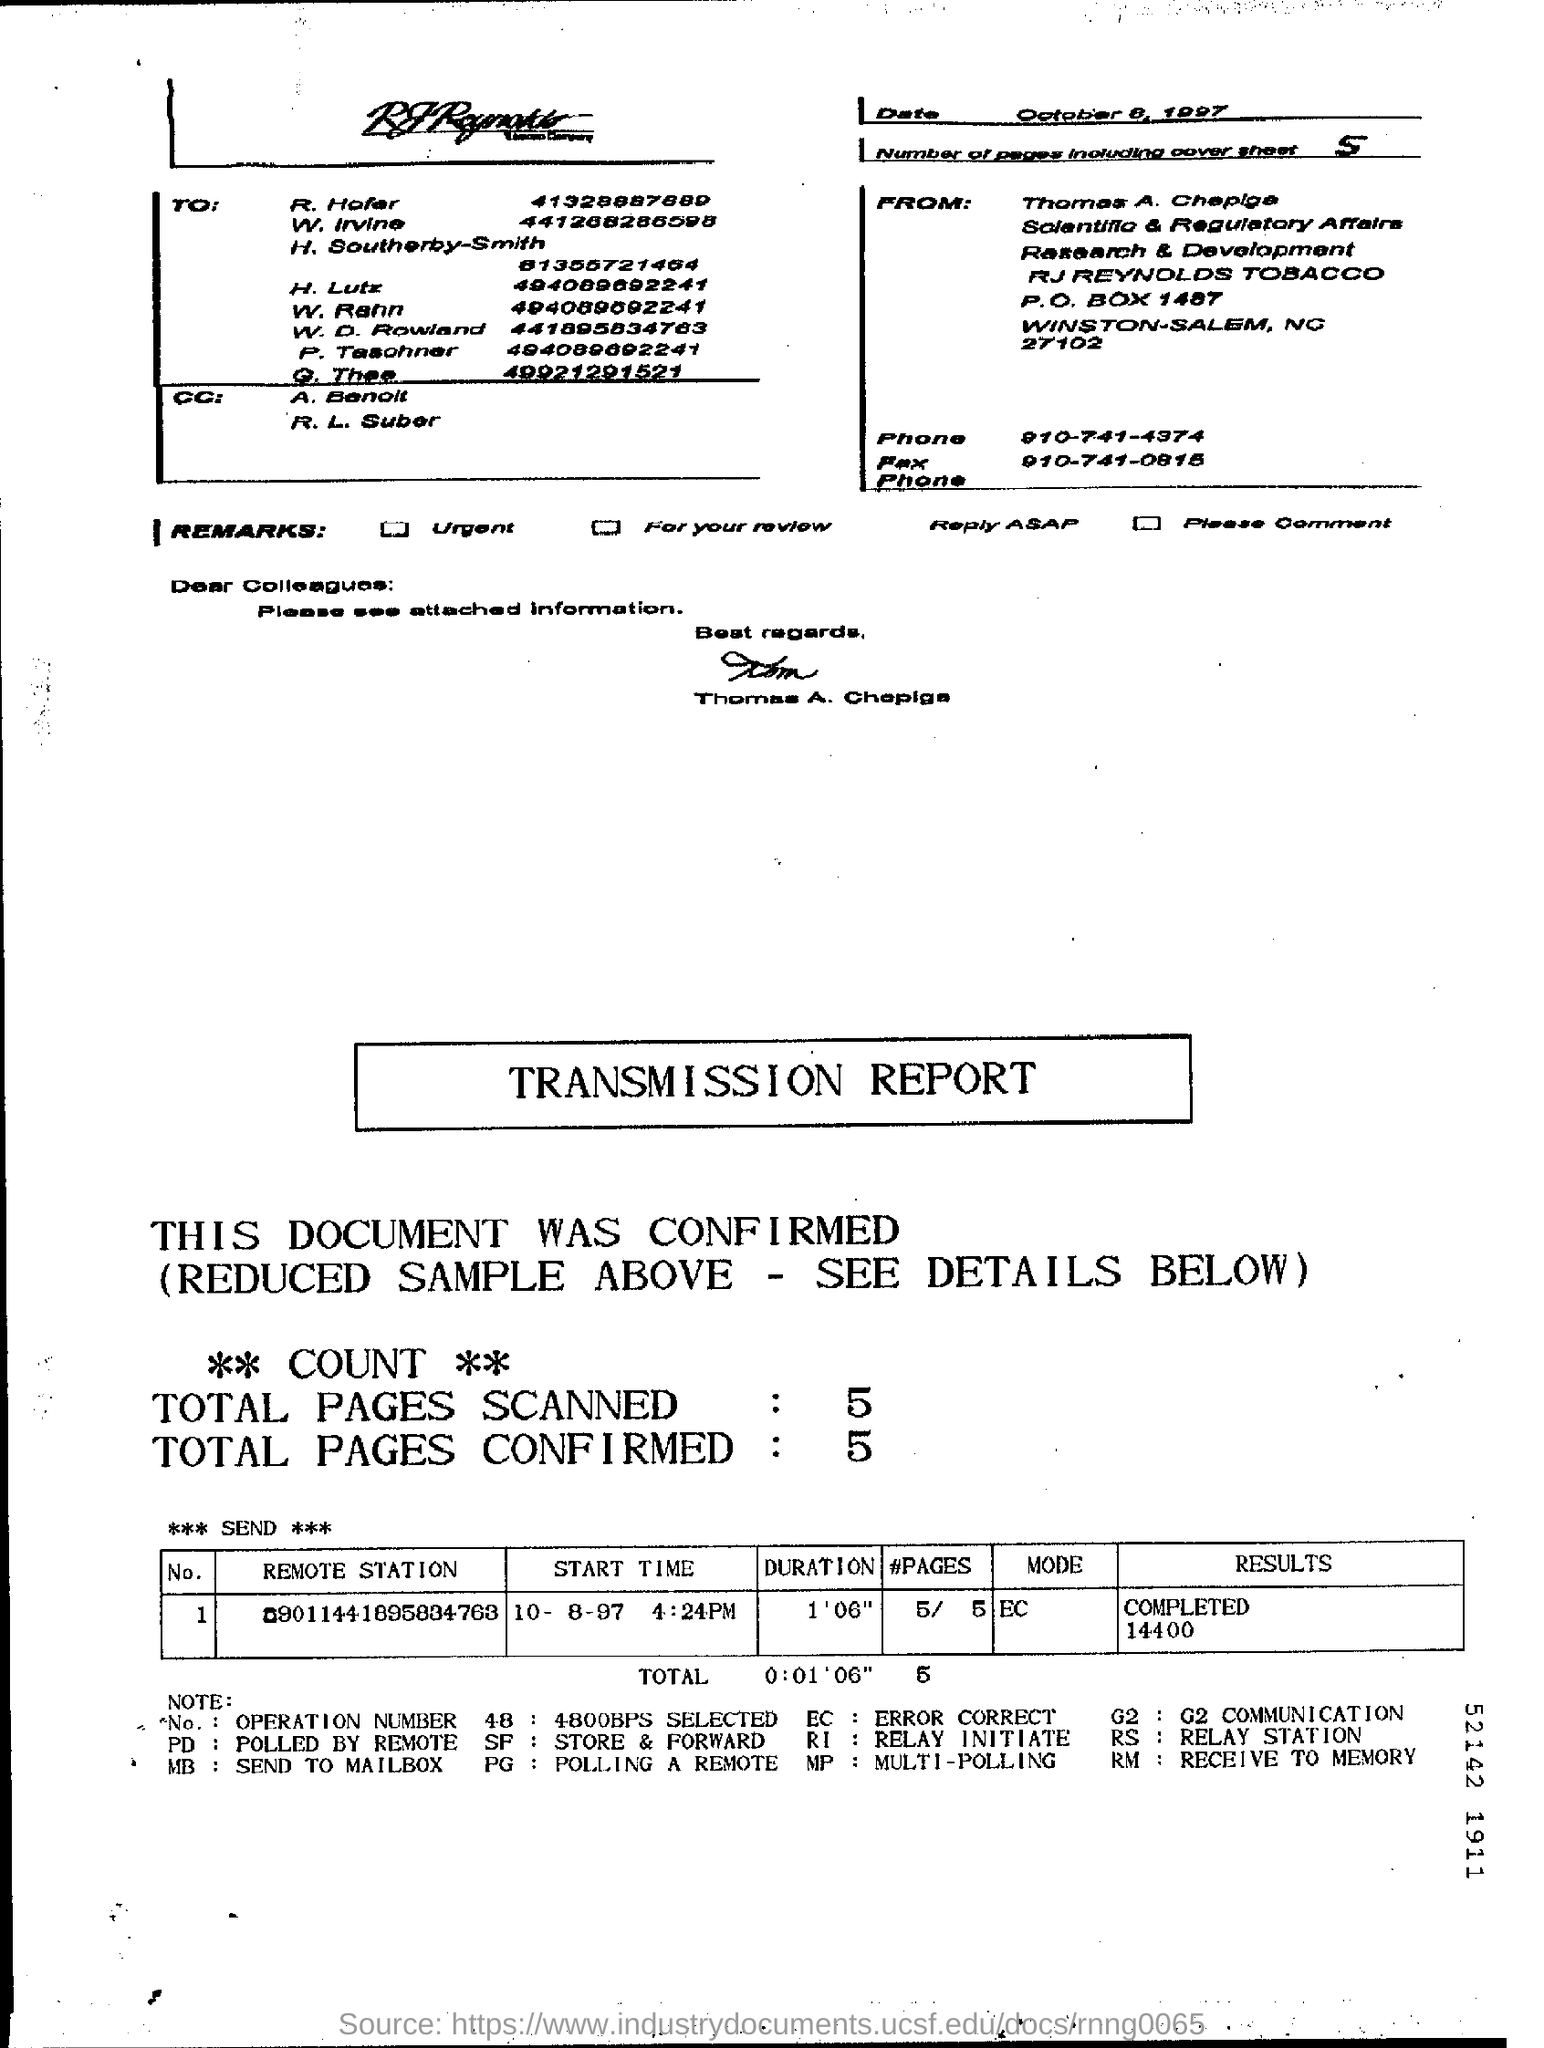Who is the sender of the Fax?
Ensure brevity in your answer.  Thomas A. Chepiga. What is the number of pages in the fax including cover sheet?
Give a very brief answer. 5. What is the Fax phone no of Thomas A. Chepiga?
Make the answer very short. 910-741-0815. 